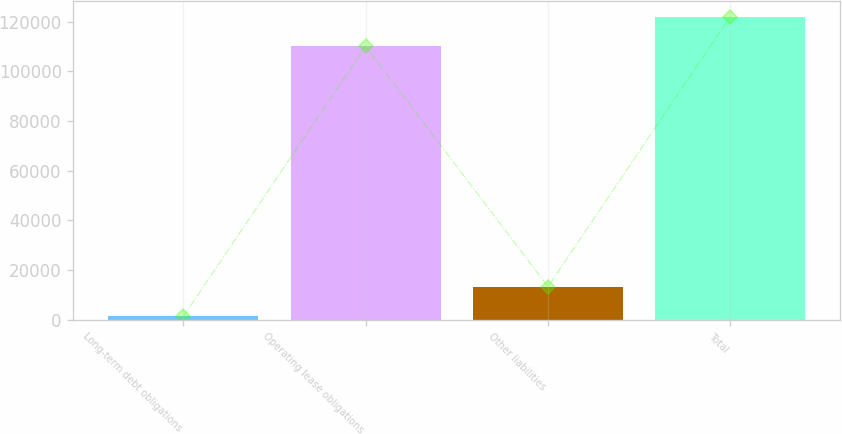Convert chart to OTSL. <chart><loc_0><loc_0><loc_500><loc_500><bar_chart><fcel>Long-term debt obligations<fcel>Operating lease obligations<fcel>Other liabilities<fcel>Total<nl><fcel>1261<fcel>109982<fcel>13293.5<fcel>122014<nl></chart> 